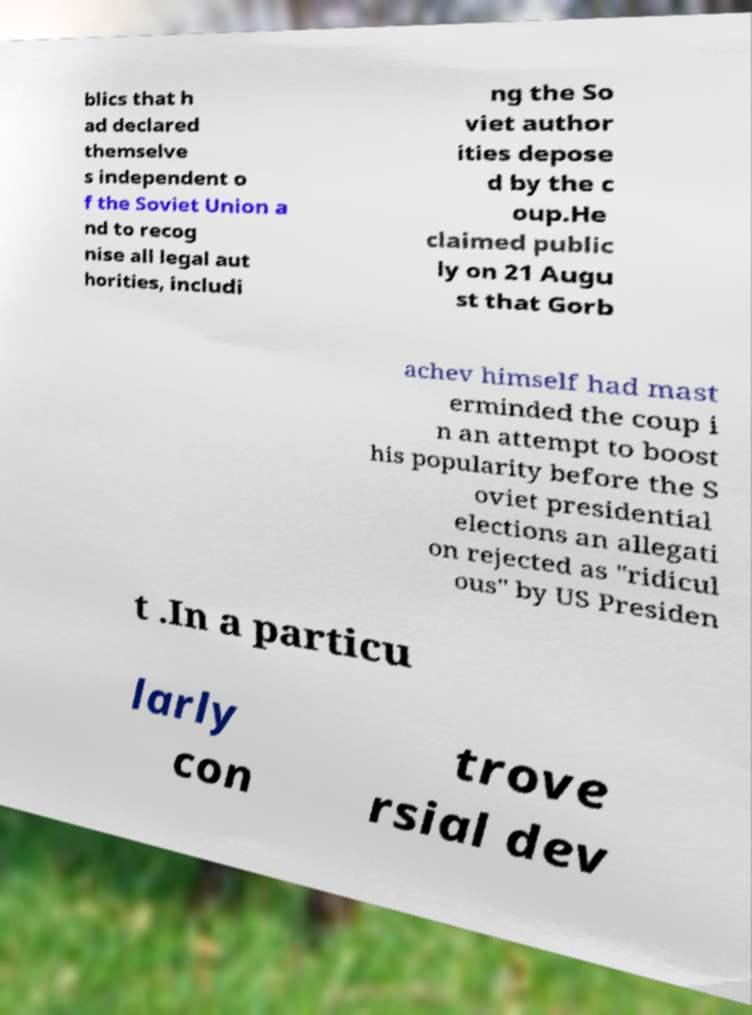There's text embedded in this image that I need extracted. Can you transcribe it verbatim? blics that h ad declared themselve s independent o f the Soviet Union a nd to recog nise all legal aut horities, includi ng the So viet author ities depose d by the c oup.He claimed public ly on 21 Augu st that Gorb achev himself had mast erminded the coup i n an attempt to boost his popularity before the S oviet presidential elections an allegati on rejected as "ridicul ous" by US Presiden t .In a particu larly con trove rsial dev 